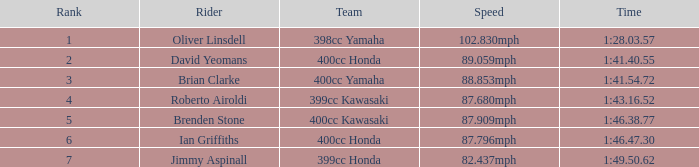4 2.0. 